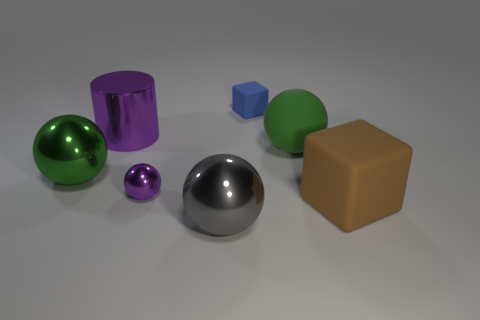Which objects in the image reflect light most intensely? The silver sphere and the green sphere reflect light most intensely, indicating that they have smooth and possibly metallic surfaces. 